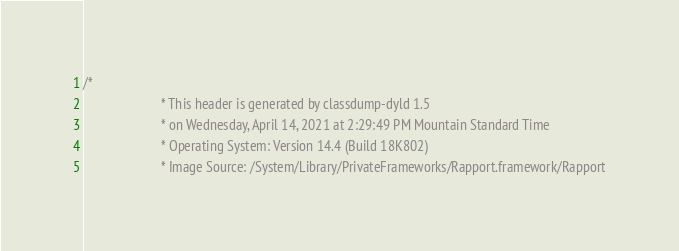Convert code to text. <code><loc_0><loc_0><loc_500><loc_500><_C_>/*
                       * This header is generated by classdump-dyld 1.5
                       * on Wednesday, April 14, 2021 at 2:29:49 PM Mountain Standard Time
                       * Operating System: Version 14.4 (Build 18K802)
                       * Image Source: /System/Library/PrivateFrameworks/Rapport.framework/Rapport</code> 